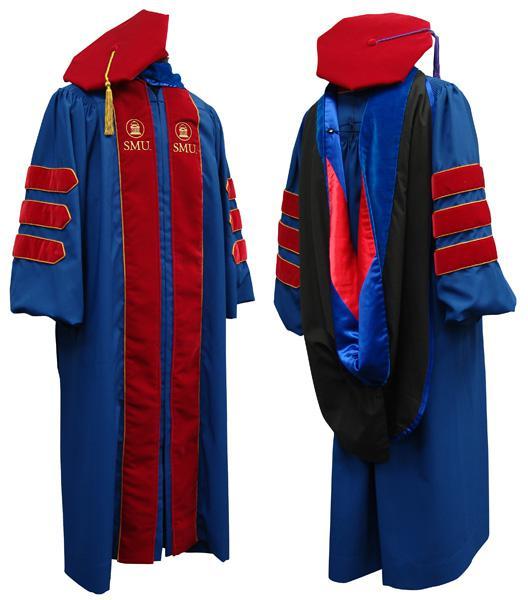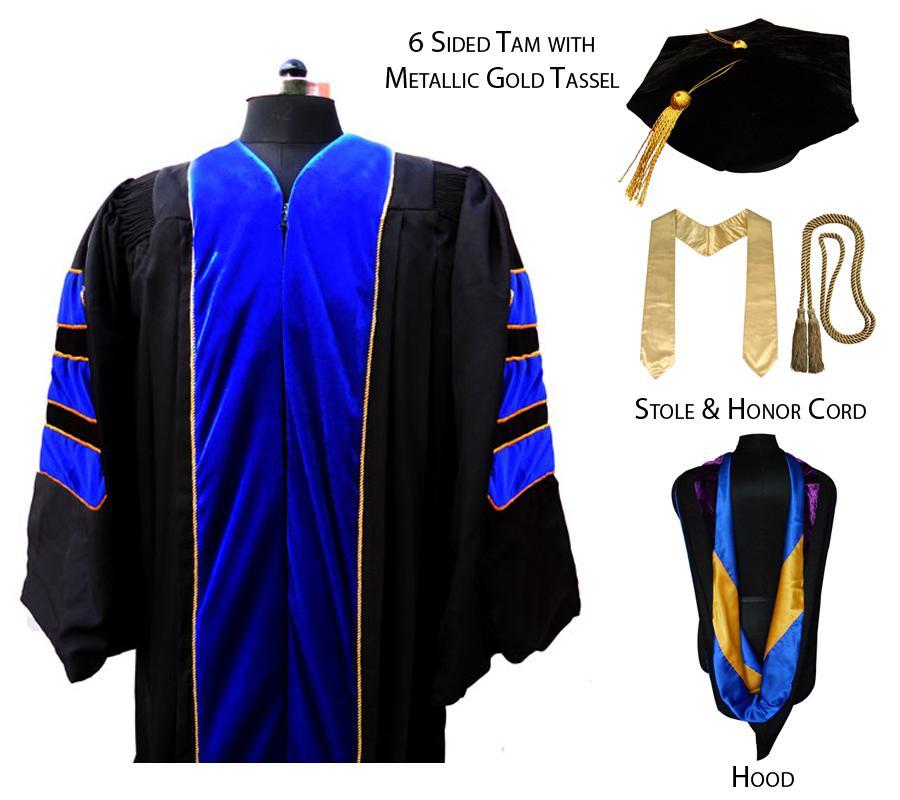The first image is the image on the left, the second image is the image on the right. Analyze the images presented: Is the assertion "Both images contain red and blue." valid? Answer yes or no. No. The first image is the image on the left, the second image is the image on the right. Evaluate the accuracy of this statement regarding the images: "All of the graduation caps are blue.". Is it true? Answer yes or no. No. 